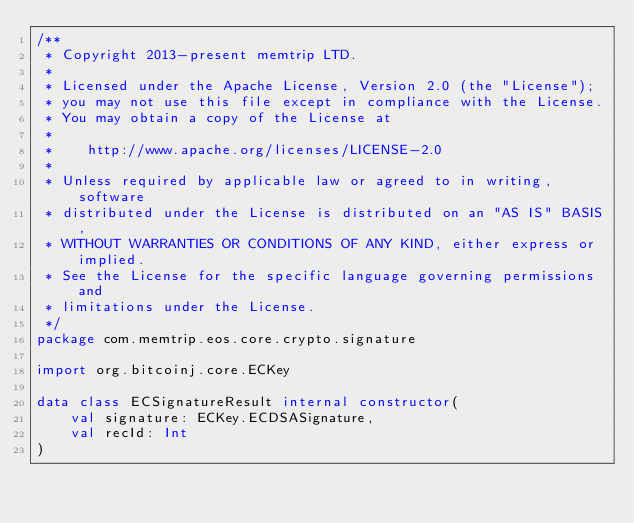Convert code to text. <code><loc_0><loc_0><loc_500><loc_500><_Kotlin_>/**
 * Copyright 2013-present memtrip LTD.
 *
 * Licensed under the Apache License, Version 2.0 (the "License");
 * you may not use this file except in compliance with the License.
 * You may obtain a copy of the License at
 *
 *    http://www.apache.org/licenses/LICENSE-2.0
 *
 * Unless required by applicable law or agreed to in writing, software
 * distributed under the License is distributed on an "AS IS" BASIS,
 * WITHOUT WARRANTIES OR CONDITIONS OF ANY KIND, either express or implied.
 * See the License for the specific language governing permissions and
 * limitations under the License.
 */
package com.memtrip.eos.core.crypto.signature

import org.bitcoinj.core.ECKey

data class ECSignatureResult internal constructor(
    val signature: ECKey.ECDSASignature,
    val recId: Int
)</code> 